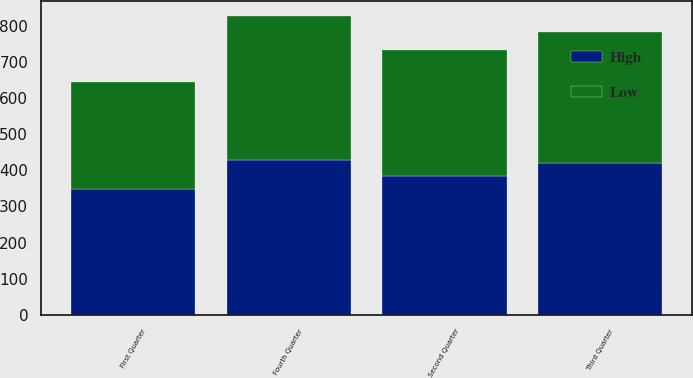Convert chart to OTSL. <chart><loc_0><loc_0><loc_500><loc_500><stacked_bar_chart><ecel><fcel>Fourth Quarter<fcel>Third Quarter<fcel>Second Quarter<fcel>First Quarter<nl><fcel>High<fcel>429.91<fcel>419.83<fcel>385.5<fcel>347.09<nl><fcel>Low<fcel>397.73<fcel>363.19<fcel>347.76<fcel>298.14<nl></chart> 